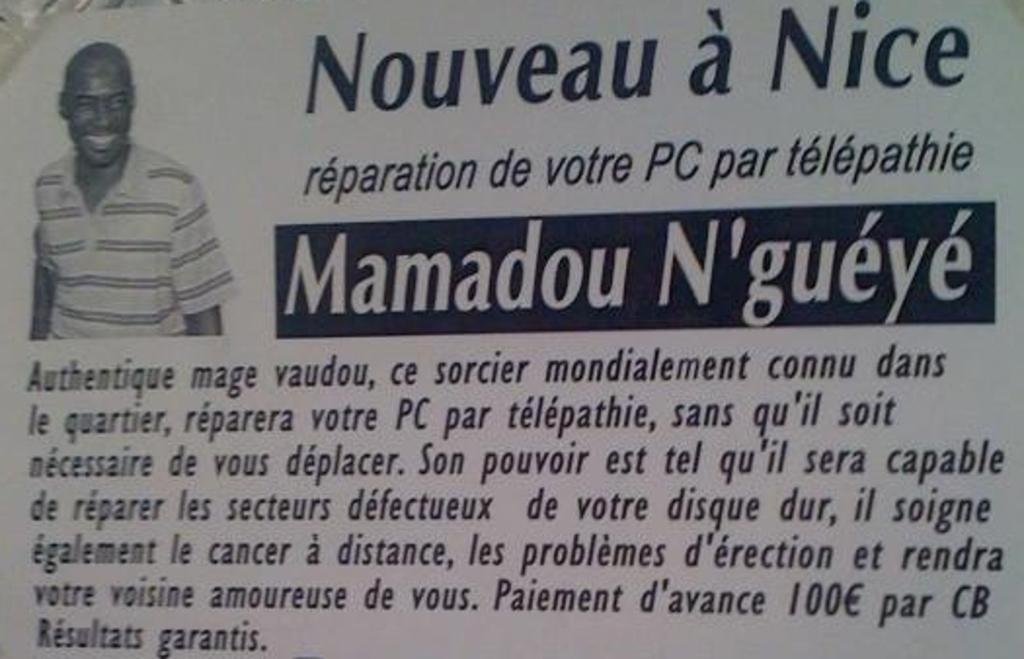What is present in the image that features an image and text? There is a poster in the image. What type of image is on the poster? The poster contains an image of a man. What else can be found on the poster besides the image? There is text on the poster. How does the crowd react to the purpose of the poster in the image? There is no crowd present in the image, so it is not possible to determine how they might react to the poster's purpose. 